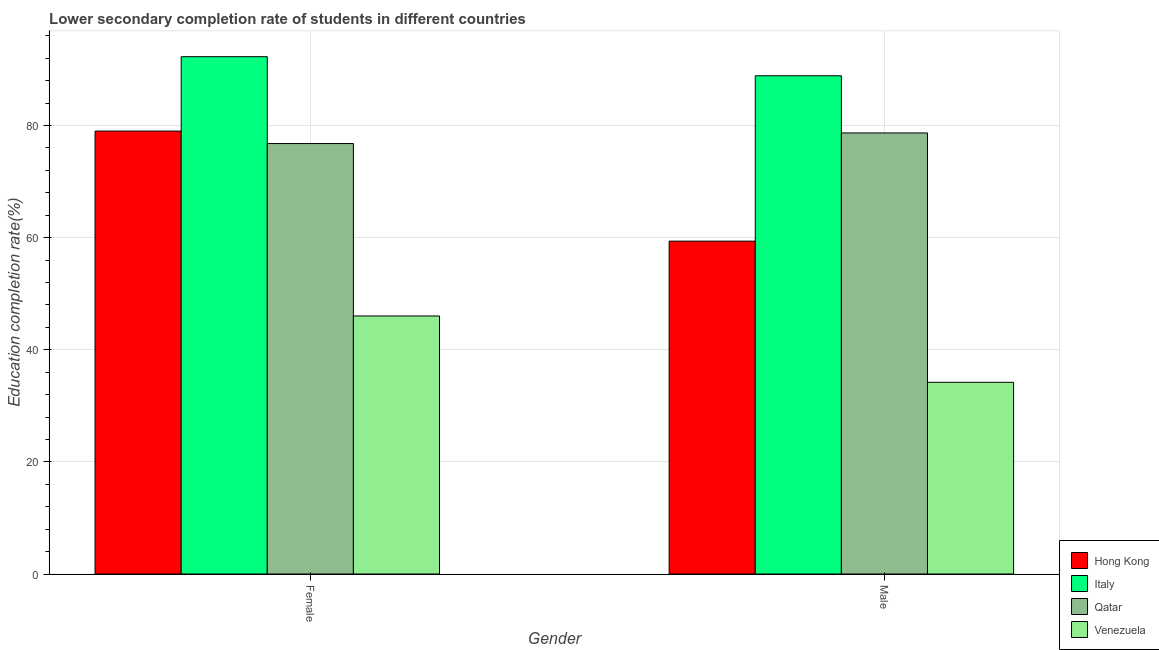How many different coloured bars are there?
Offer a very short reply. 4. How many groups of bars are there?
Offer a very short reply. 2. Are the number of bars on each tick of the X-axis equal?
Make the answer very short. Yes. How many bars are there on the 2nd tick from the left?
Your answer should be very brief. 4. What is the education completion rate of female students in Venezuela?
Ensure brevity in your answer.  46.02. Across all countries, what is the maximum education completion rate of male students?
Provide a short and direct response. 88.86. Across all countries, what is the minimum education completion rate of male students?
Offer a very short reply. 34.19. In which country was the education completion rate of female students minimum?
Offer a terse response. Venezuela. What is the total education completion rate of female students in the graph?
Offer a very short reply. 294.05. What is the difference between the education completion rate of male students in Italy and that in Qatar?
Provide a short and direct response. 10.19. What is the difference between the education completion rate of female students in Venezuela and the education completion rate of male students in Hong Kong?
Provide a short and direct response. -13.35. What is the average education completion rate of female students per country?
Give a very brief answer. 73.51. What is the difference between the education completion rate of female students and education completion rate of male students in Hong Kong?
Your answer should be compact. 19.63. What is the ratio of the education completion rate of male students in Italy to that in Qatar?
Offer a terse response. 1.13. Is the education completion rate of female students in Qatar less than that in Venezuela?
Your response must be concise. No. What does the 2nd bar from the left in Male represents?
Make the answer very short. Italy. What does the 1st bar from the right in Female represents?
Make the answer very short. Venezuela. What is the difference between two consecutive major ticks on the Y-axis?
Ensure brevity in your answer.  20. Does the graph contain any zero values?
Provide a short and direct response. No. Where does the legend appear in the graph?
Give a very brief answer. Bottom right. What is the title of the graph?
Provide a succinct answer. Lower secondary completion rate of students in different countries. What is the label or title of the Y-axis?
Offer a very short reply. Education completion rate(%). What is the Education completion rate(%) in Hong Kong in Female?
Your answer should be very brief. 79. What is the Education completion rate(%) in Italy in Female?
Give a very brief answer. 92.26. What is the Education completion rate(%) of Qatar in Female?
Provide a short and direct response. 76.77. What is the Education completion rate(%) in Venezuela in Female?
Provide a succinct answer. 46.02. What is the Education completion rate(%) of Hong Kong in Male?
Your response must be concise. 59.37. What is the Education completion rate(%) of Italy in Male?
Provide a short and direct response. 88.86. What is the Education completion rate(%) in Qatar in Male?
Offer a very short reply. 78.66. What is the Education completion rate(%) in Venezuela in Male?
Your answer should be very brief. 34.19. Across all Gender, what is the maximum Education completion rate(%) of Hong Kong?
Ensure brevity in your answer.  79. Across all Gender, what is the maximum Education completion rate(%) in Italy?
Make the answer very short. 92.26. Across all Gender, what is the maximum Education completion rate(%) in Qatar?
Offer a very short reply. 78.66. Across all Gender, what is the maximum Education completion rate(%) in Venezuela?
Offer a terse response. 46.02. Across all Gender, what is the minimum Education completion rate(%) of Hong Kong?
Your answer should be compact. 59.37. Across all Gender, what is the minimum Education completion rate(%) in Italy?
Your response must be concise. 88.86. Across all Gender, what is the minimum Education completion rate(%) of Qatar?
Provide a succinct answer. 76.77. Across all Gender, what is the minimum Education completion rate(%) of Venezuela?
Your response must be concise. 34.19. What is the total Education completion rate(%) in Hong Kong in the graph?
Keep it short and to the point. 138.36. What is the total Education completion rate(%) in Italy in the graph?
Provide a succinct answer. 181.12. What is the total Education completion rate(%) in Qatar in the graph?
Offer a very short reply. 155.43. What is the total Education completion rate(%) of Venezuela in the graph?
Offer a terse response. 80.21. What is the difference between the Education completion rate(%) in Hong Kong in Female and that in Male?
Your answer should be compact. 19.63. What is the difference between the Education completion rate(%) of Italy in Female and that in Male?
Make the answer very short. 3.41. What is the difference between the Education completion rate(%) of Qatar in Female and that in Male?
Ensure brevity in your answer.  -1.89. What is the difference between the Education completion rate(%) in Venezuela in Female and that in Male?
Provide a succinct answer. 11.83. What is the difference between the Education completion rate(%) in Hong Kong in Female and the Education completion rate(%) in Italy in Male?
Keep it short and to the point. -9.86. What is the difference between the Education completion rate(%) in Hong Kong in Female and the Education completion rate(%) in Qatar in Male?
Provide a short and direct response. 0.33. What is the difference between the Education completion rate(%) of Hong Kong in Female and the Education completion rate(%) of Venezuela in Male?
Offer a very short reply. 44.81. What is the difference between the Education completion rate(%) in Italy in Female and the Education completion rate(%) in Qatar in Male?
Offer a very short reply. 13.6. What is the difference between the Education completion rate(%) of Italy in Female and the Education completion rate(%) of Venezuela in Male?
Provide a short and direct response. 58.07. What is the difference between the Education completion rate(%) of Qatar in Female and the Education completion rate(%) of Venezuela in Male?
Provide a short and direct response. 42.58. What is the average Education completion rate(%) of Hong Kong per Gender?
Your answer should be compact. 69.18. What is the average Education completion rate(%) of Italy per Gender?
Your answer should be compact. 90.56. What is the average Education completion rate(%) of Qatar per Gender?
Keep it short and to the point. 77.72. What is the average Education completion rate(%) of Venezuela per Gender?
Offer a terse response. 40.1. What is the difference between the Education completion rate(%) in Hong Kong and Education completion rate(%) in Italy in Female?
Your answer should be compact. -13.27. What is the difference between the Education completion rate(%) in Hong Kong and Education completion rate(%) in Qatar in Female?
Offer a terse response. 2.23. What is the difference between the Education completion rate(%) in Hong Kong and Education completion rate(%) in Venezuela in Female?
Ensure brevity in your answer.  32.98. What is the difference between the Education completion rate(%) of Italy and Education completion rate(%) of Qatar in Female?
Offer a very short reply. 15.49. What is the difference between the Education completion rate(%) in Italy and Education completion rate(%) in Venezuela in Female?
Keep it short and to the point. 46.24. What is the difference between the Education completion rate(%) in Qatar and Education completion rate(%) in Venezuela in Female?
Provide a succinct answer. 30.75. What is the difference between the Education completion rate(%) of Hong Kong and Education completion rate(%) of Italy in Male?
Ensure brevity in your answer.  -29.49. What is the difference between the Education completion rate(%) in Hong Kong and Education completion rate(%) in Qatar in Male?
Provide a succinct answer. -19.3. What is the difference between the Education completion rate(%) of Hong Kong and Education completion rate(%) of Venezuela in Male?
Provide a short and direct response. 25.18. What is the difference between the Education completion rate(%) in Italy and Education completion rate(%) in Qatar in Male?
Give a very brief answer. 10.19. What is the difference between the Education completion rate(%) in Italy and Education completion rate(%) in Venezuela in Male?
Provide a short and direct response. 54.67. What is the difference between the Education completion rate(%) in Qatar and Education completion rate(%) in Venezuela in Male?
Your answer should be very brief. 44.47. What is the ratio of the Education completion rate(%) of Hong Kong in Female to that in Male?
Provide a succinct answer. 1.33. What is the ratio of the Education completion rate(%) in Italy in Female to that in Male?
Offer a terse response. 1.04. What is the ratio of the Education completion rate(%) in Qatar in Female to that in Male?
Your answer should be compact. 0.98. What is the ratio of the Education completion rate(%) of Venezuela in Female to that in Male?
Ensure brevity in your answer.  1.35. What is the difference between the highest and the second highest Education completion rate(%) in Hong Kong?
Your response must be concise. 19.63. What is the difference between the highest and the second highest Education completion rate(%) of Italy?
Offer a very short reply. 3.41. What is the difference between the highest and the second highest Education completion rate(%) of Qatar?
Your response must be concise. 1.89. What is the difference between the highest and the second highest Education completion rate(%) of Venezuela?
Make the answer very short. 11.83. What is the difference between the highest and the lowest Education completion rate(%) in Hong Kong?
Provide a succinct answer. 19.63. What is the difference between the highest and the lowest Education completion rate(%) of Italy?
Your answer should be very brief. 3.41. What is the difference between the highest and the lowest Education completion rate(%) in Qatar?
Your answer should be very brief. 1.89. What is the difference between the highest and the lowest Education completion rate(%) in Venezuela?
Provide a succinct answer. 11.83. 